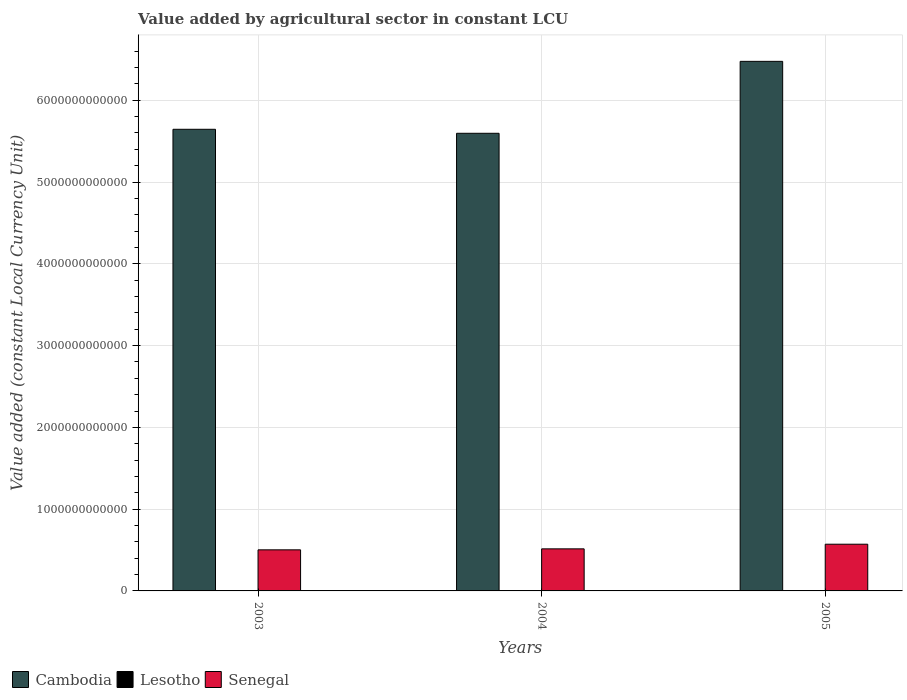How many groups of bars are there?
Your answer should be very brief. 3. Are the number of bars per tick equal to the number of legend labels?
Keep it short and to the point. Yes. Are the number of bars on each tick of the X-axis equal?
Your response must be concise. Yes. How many bars are there on the 3rd tick from the left?
Offer a very short reply. 3. What is the value added by agricultural sector in Cambodia in 2005?
Provide a succinct answer. 6.48e+12. Across all years, what is the maximum value added by agricultural sector in Cambodia?
Ensure brevity in your answer.  6.48e+12. Across all years, what is the minimum value added by agricultural sector in Senegal?
Keep it short and to the point. 5.02e+11. In which year was the value added by agricultural sector in Lesotho maximum?
Give a very brief answer. 2005. In which year was the value added by agricultural sector in Senegal minimum?
Your answer should be very brief. 2003. What is the total value added by agricultural sector in Cambodia in the graph?
Give a very brief answer. 1.77e+13. What is the difference between the value added by agricultural sector in Senegal in 2003 and that in 2004?
Ensure brevity in your answer.  -1.20e+1. What is the difference between the value added by agricultural sector in Senegal in 2005 and the value added by agricultural sector in Lesotho in 2004?
Your answer should be compact. 5.70e+11. What is the average value added by agricultural sector in Lesotho per year?
Offer a very short reply. 7.07e+08. In the year 2003, what is the difference between the value added by agricultural sector in Lesotho and value added by agricultural sector in Cambodia?
Provide a succinct answer. -5.64e+12. What is the ratio of the value added by agricultural sector in Cambodia in 2003 to that in 2005?
Your answer should be compact. 0.87. What is the difference between the highest and the second highest value added by agricultural sector in Lesotho?
Your answer should be compact. 3.31e+06. What is the difference between the highest and the lowest value added by agricultural sector in Senegal?
Keep it short and to the point. 6.87e+1. In how many years, is the value added by agricultural sector in Cambodia greater than the average value added by agricultural sector in Cambodia taken over all years?
Ensure brevity in your answer.  1. Is the sum of the value added by agricultural sector in Cambodia in 2003 and 2004 greater than the maximum value added by agricultural sector in Lesotho across all years?
Offer a very short reply. Yes. What does the 3rd bar from the left in 2003 represents?
Make the answer very short. Senegal. What does the 2nd bar from the right in 2004 represents?
Your answer should be very brief. Lesotho. Is it the case that in every year, the sum of the value added by agricultural sector in Senegal and value added by agricultural sector in Lesotho is greater than the value added by agricultural sector in Cambodia?
Your answer should be very brief. No. What is the difference between two consecutive major ticks on the Y-axis?
Provide a short and direct response. 1.00e+12. How many legend labels are there?
Keep it short and to the point. 3. How are the legend labels stacked?
Your response must be concise. Horizontal. What is the title of the graph?
Keep it short and to the point. Value added by agricultural sector in constant LCU. Does "Turkey" appear as one of the legend labels in the graph?
Offer a very short reply. No. What is the label or title of the Y-axis?
Ensure brevity in your answer.  Value added (constant Local Currency Unit). What is the Value added (constant Local Currency Unit) of Cambodia in 2003?
Give a very brief answer. 5.64e+12. What is the Value added (constant Local Currency Unit) in Lesotho in 2003?
Keep it short and to the point. 7.09e+08. What is the Value added (constant Local Currency Unit) of Senegal in 2003?
Offer a very short reply. 5.02e+11. What is the Value added (constant Local Currency Unit) of Cambodia in 2004?
Give a very brief answer. 5.60e+12. What is the Value added (constant Local Currency Unit) of Lesotho in 2004?
Make the answer very short. 7.02e+08. What is the Value added (constant Local Currency Unit) of Senegal in 2004?
Offer a terse response. 5.14e+11. What is the Value added (constant Local Currency Unit) of Cambodia in 2005?
Your answer should be compact. 6.48e+12. What is the Value added (constant Local Currency Unit) of Lesotho in 2005?
Your answer should be very brief. 7.12e+08. What is the Value added (constant Local Currency Unit) of Senegal in 2005?
Provide a succinct answer. 5.71e+11. Across all years, what is the maximum Value added (constant Local Currency Unit) of Cambodia?
Keep it short and to the point. 6.48e+12. Across all years, what is the maximum Value added (constant Local Currency Unit) in Lesotho?
Offer a very short reply. 7.12e+08. Across all years, what is the maximum Value added (constant Local Currency Unit) in Senegal?
Give a very brief answer. 5.71e+11. Across all years, what is the minimum Value added (constant Local Currency Unit) in Cambodia?
Provide a succinct answer. 5.60e+12. Across all years, what is the minimum Value added (constant Local Currency Unit) in Lesotho?
Offer a terse response. 7.02e+08. Across all years, what is the minimum Value added (constant Local Currency Unit) of Senegal?
Your answer should be very brief. 5.02e+11. What is the total Value added (constant Local Currency Unit) of Cambodia in the graph?
Make the answer very short. 1.77e+13. What is the total Value added (constant Local Currency Unit) of Lesotho in the graph?
Provide a succinct answer. 2.12e+09. What is the total Value added (constant Local Currency Unit) of Senegal in the graph?
Offer a very short reply. 1.59e+12. What is the difference between the Value added (constant Local Currency Unit) of Cambodia in 2003 and that in 2004?
Ensure brevity in your answer.  4.89e+1. What is the difference between the Value added (constant Local Currency Unit) of Lesotho in 2003 and that in 2004?
Your response must be concise. 6.57e+06. What is the difference between the Value added (constant Local Currency Unit) in Senegal in 2003 and that in 2004?
Keep it short and to the point. -1.20e+1. What is the difference between the Value added (constant Local Currency Unit) of Cambodia in 2003 and that in 2005?
Keep it short and to the point. -8.31e+11. What is the difference between the Value added (constant Local Currency Unit) in Lesotho in 2003 and that in 2005?
Keep it short and to the point. -3.31e+06. What is the difference between the Value added (constant Local Currency Unit) of Senegal in 2003 and that in 2005?
Provide a short and direct response. -6.87e+1. What is the difference between the Value added (constant Local Currency Unit) of Cambodia in 2004 and that in 2005?
Offer a very short reply. -8.80e+11. What is the difference between the Value added (constant Local Currency Unit) of Lesotho in 2004 and that in 2005?
Ensure brevity in your answer.  -9.87e+06. What is the difference between the Value added (constant Local Currency Unit) of Senegal in 2004 and that in 2005?
Provide a short and direct response. -5.67e+1. What is the difference between the Value added (constant Local Currency Unit) of Cambodia in 2003 and the Value added (constant Local Currency Unit) of Lesotho in 2004?
Make the answer very short. 5.64e+12. What is the difference between the Value added (constant Local Currency Unit) of Cambodia in 2003 and the Value added (constant Local Currency Unit) of Senegal in 2004?
Make the answer very short. 5.13e+12. What is the difference between the Value added (constant Local Currency Unit) in Lesotho in 2003 and the Value added (constant Local Currency Unit) in Senegal in 2004?
Ensure brevity in your answer.  -5.14e+11. What is the difference between the Value added (constant Local Currency Unit) in Cambodia in 2003 and the Value added (constant Local Currency Unit) in Lesotho in 2005?
Ensure brevity in your answer.  5.64e+12. What is the difference between the Value added (constant Local Currency Unit) in Cambodia in 2003 and the Value added (constant Local Currency Unit) in Senegal in 2005?
Your response must be concise. 5.07e+12. What is the difference between the Value added (constant Local Currency Unit) in Lesotho in 2003 and the Value added (constant Local Currency Unit) in Senegal in 2005?
Provide a short and direct response. -5.70e+11. What is the difference between the Value added (constant Local Currency Unit) in Cambodia in 2004 and the Value added (constant Local Currency Unit) in Lesotho in 2005?
Your answer should be very brief. 5.60e+12. What is the difference between the Value added (constant Local Currency Unit) of Cambodia in 2004 and the Value added (constant Local Currency Unit) of Senegal in 2005?
Offer a terse response. 5.02e+12. What is the difference between the Value added (constant Local Currency Unit) in Lesotho in 2004 and the Value added (constant Local Currency Unit) in Senegal in 2005?
Your answer should be compact. -5.70e+11. What is the average Value added (constant Local Currency Unit) in Cambodia per year?
Provide a short and direct response. 5.91e+12. What is the average Value added (constant Local Currency Unit) of Lesotho per year?
Keep it short and to the point. 7.07e+08. What is the average Value added (constant Local Currency Unit) in Senegal per year?
Ensure brevity in your answer.  5.29e+11. In the year 2003, what is the difference between the Value added (constant Local Currency Unit) of Cambodia and Value added (constant Local Currency Unit) of Lesotho?
Keep it short and to the point. 5.64e+12. In the year 2003, what is the difference between the Value added (constant Local Currency Unit) in Cambodia and Value added (constant Local Currency Unit) in Senegal?
Keep it short and to the point. 5.14e+12. In the year 2003, what is the difference between the Value added (constant Local Currency Unit) in Lesotho and Value added (constant Local Currency Unit) in Senegal?
Offer a terse response. -5.02e+11. In the year 2004, what is the difference between the Value added (constant Local Currency Unit) of Cambodia and Value added (constant Local Currency Unit) of Lesotho?
Your answer should be very brief. 5.60e+12. In the year 2004, what is the difference between the Value added (constant Local Currency Unit) of Cambodia and Value added (constant Local Currency Unit) of Senegal?
Offer a very short reply. 5.08e+12. In the year 2004, what is the difference between the Value added (constant Local Currency Unit) in Lesotho and Value added (constant Local Currency Unit) in Senegal?
Provide a short and direct response. -5.14e+11. In the year 2005, what is the difference between the Value added (constant Local Currency Unit) in Cambodia and Value added (constant Local Currency Unit) in Lesotho?
Give a very brief answer. 6.47e+12. In the year 2005, what is the difference between the Value added (constant Local Currency Unit) of Cambodia and Value added (constant Local Currency Unit) of Senegal?
Provide a short and direct response. 5.90e+12. In the year 2005, what is the difference between the Value added (constant Local Currency Unit) of Lesotho and Value added (constant Local Currency Unit) of Senegal?
Give a very brief answer. -5.70e+11. What is the ratio of the Value added (constant Local Currency Unit) in Cambodia in 2003 to that in 2004?
Provide a short and direct response. 1.01. What is the ratio of the Value added (constant Local Currency Unit) of Lesotho in 2003 to that in 2004?
Give a very brief answer. 1.01. What is the ratio of the Value added (constant Local Currency Unit) of Senegal in 2003 to that in 2004?
Provide a short and direct response. 0.98. What is the ratio of the Value added (constant Local Currency Unit) of Cambodia in 2003 to that in 2005?
Make the answer very short. 0.87. What is the ratio of the Value added (constant Local Currency Unit) of Lesotho in 2003 to that in 2005?
Offer a terse response. 1. What is the ratio of the Value added (constant Local Currency Unit) of Senegal in 2003 to that in 2005?
Your answer should be compact. 0.88. What is the ratio of the Value added (constant Local Currency Unit) of Cambodia in 2004 to that in 2005?
Offer a terse response. 0.86. What is the ratio of the Value added (constant Local Currency Unit) of Lesotho in 2004 to that in 2005?
Make the answer very short. 0.99. What is the ratio of the Value added (constant Local Currency Unit) in Senegal in 2004 to that in 2005?
Make the answer very short. 0.9. What is the difference between the highest and the second highest Value added (constant Local Currency Unit) in Cambodia?
Provide a succinct answer. 8.31e+11. What is the difference between the highest and the second highest Value added (constant Local Currency Unit) in Lesotho?
Your answer should be compact. 3.31e+06. What is the difference between the highest and the second highest Value added (constant Local Currency Unit) of Senegal?
Offer a very short reply. 5.67e+1. What is the difference between the highest and the lowest Value added (constant Local Currency Unit) of Cambodia?
Make the answer very short. 8.80e+11. What is the difference between the highest and the lowest Value added (constant Local Currency Unit) of Lesotho?
Provide a succinct answer. 9.87e+06. What is the difference between the highest and the lowest Value added (constant Local Currency Unit) of Senegal?
Your answer should be compact. 6.87e+1. 